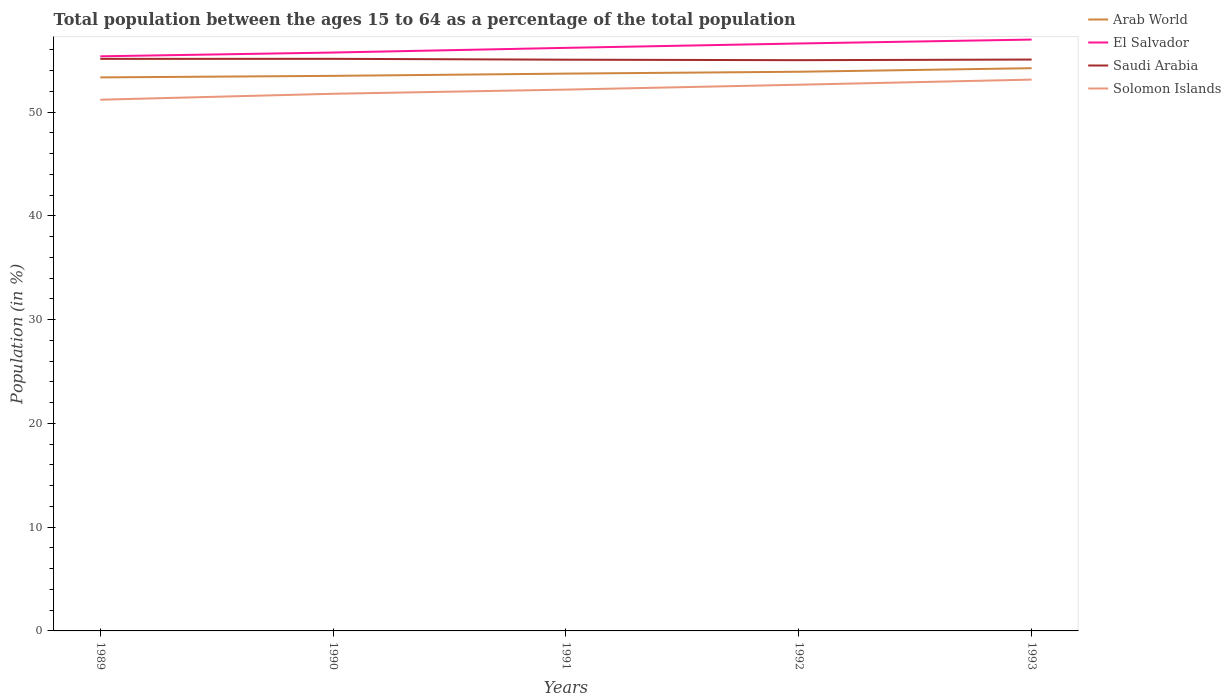Is the number of lines equal to the number of legend labels?
Offer a very short reply. Yes. Across all years, what is the maximum percentage of the population ages 15 to 64 in Solomon Islands?
Make the answer very short. 51.19. In which year was the percentage of the population ages 15 to 64 in Solomon Islands maximum?
Offer a very short reply. 1989. What is the total percentage of the population ages 15 to 64 in El Salvador in the graph?
Provide a succinct answer. -1.61. What is the difference between the highest and the second highest percentage of the population ages 15 to 64 in Arab World?
Give a very brief answer. 0.89. What is the difference between the highest and the lowest percentage of the population ages 15 to 64 in Saudi Arabia?
Your response must be concise. 2. How many lines are there?
Ensure brevity in your answer.  4. How many years are there in the graph?
Give a very brief answer. 5. What is the difference between two consecutive major ticks on the Y-axis?
Make the answer very short. 10. Does the graph contain any zero values?
Keep it short and to the point. No. Does the graph contain grids?
Your response must be concise. No. Where does the legend appear in the graph?
Provide a short and direct response. Top right. What is the title of the graph?
Ensure brevity in your answer.  Total population between the ages 15 to 64 as a percentage of the total population. What is the label or title of the Y-axis?
Offer a very short reply. Population (in %). What is the Population (in %) in Arab World in 1989?
Your response must be concise. 53.35. What is the Population (in %) of El Salvador in 1989?
Make the answer very short. 55.38. What is the Population (in %) of Saudi Arabia in 1989?
Offer a very short reply. 55.13. What is the Population (in %) of Solomon Islands in 1989?
Ensure brevity in your answer.  51.19. What is the Population (in %) in Arab World in 1990?
Offer a very short reply. 53.49. What is the Population (in %) of El Salvador in 1990?
Provide a succinct answer. 55.74. What is the Population (in %) in Saudi Arabia in 1990?
Give a very brief answer. 55.13. What is the Population (in %) of Solomon Islands in 1990?
Provide a short and direct response. 51.77. What is the Population (in %) of Arab World in 1991?
Provide a short and direct response. 53.71. What is the Population (in %) of El Salvador in 1991?
Your answer should be very brief. 56.19. What is the Population (in %) in Saudi Arabia in 1991?
Ensure brevity in your answer.  55.05. What is the Population (in %) of Solomon Islands in 1991?
Your response must be concise. 52.17. What is the Population (in %) in Arab World in 1992?
Make the answer very short. 53.89. What is the Population (in %) in El Salvador in 1992?
Ensure brevity in your answer.  56.61. What is the Population (in %) of Saudi Arabia in 1992?
Your answer should be very brief. 55.01. What is the Population (in %) in Solomon Islands in 1992?
Offer a very short reply. 52.64. What is the Population (in %) of Arab World in 1993?
Your response must be concise. 54.23. What is the Population (in %) of El Salvador in 1993?
Ensure brevity in your answer.  56.99. What is the Population (in %) in Saudi Arabia in 1993?
Keep it short and to the point. 55.07. What is the Population (in %) in Solomon Islands in 1993?
Provide a short and direct response. 53.13. Across all years, what is the maximum Population (in %) in Arab World?
Ensure brevity in your answer.  54.23. Across all years, what is the maximum Population (in %) in El Salvador?
Your answer should be compact. 56.99. Across all years, what is the maximum Population (in %) in Saudi Arabia?
Keep it short and to the point. 55.13. Across all years, what is the maximum Population (in %) of Solomon Islands?
Give a very brief answer. 53.13. Across all years, what is the minimum Population (in %) in Arab World?
Offer a terse response. 53.35. Across all years, what is the minimum Population (in %) of El Salvador?
Your answer should be very brief. 55.38. Across all years, what is the minimum Population (in %) in Saudi Arabia?
Give a very brief answer. 55.01. Across all years, what is the minimum Population (in %) of Solomon Islands?
Ensure brevity in your answer.  51.19. What is the total Population (in %) of Arab World in the graph?
Offer a terse response. 268.67. What is the total Population (in %) in El Salvador in the graph?
Keep it short and to the point. 280.91. What is the total Population (in %) in Saudi Arabia in the graph?
Make the answer very short. 275.39. What is the total Population (in %) of Solomon Islands in the graph?
Provide a succinct answer. 260.9. What is the difference between the Population (in %) of Arab World in 1989 and that in 1990?
Ensure brevity in your answer.  -0.15. What is the difference between the Population (in %) of El Salvador in 1989 and that in 1990?
Your response must be concise. -0.36. What is the difference between the Population (in %) in Saudi Arabia in 1989 and that in 1990?
Your answer should be very brief. -0. What is the difference between the Population (in %) in Solomon Islands in 1989 and that in 1990?
Give a very brief answer. -0.57. What is the difference between the Population (in %) in Arab World in 1989 and that in 1991?
Provide a short and direct response. -0.36. What is the difference between the Population (in %) in El Salvador in 1989 and that in 1991?
Your answer should be compact. -0.81. What is the difference between the Population (in %) of Saudi Arabia in 1989 and that in 1991?
Offer a very short reply. 0.08. What is the difference between the Population (in %) of Solomon Islands in 1989 and that in 1991?
Your answer should be compact. -0.97. What is the difference between the Population (in %) in Arab World in 1989 and that in 1992?
Provide a short and direct response. -0.54. What is the difference between the Population (in %) of El Salvador in 1989 and that in 1992?
Offer a terse response. -1.24. What is the difference between the Population (in %) in Saudi Arabia in 1989 and that in 1992?
Keep it short and to the point. 0.13. What is the difference between the Population (in %) in Solomon Islands in 1989 and that in 1992?
Offer a terse response. -1.44. What is the difference between the Population (in %) of Arab World in 1989 and that in 1993?
Your response must be concise. -0.89. What is the difference between the Population (in %) of El Salvador in 1989 and that in 1993?
Your answer should be very brief. -1.61. What is the difference between the Population (in %) in Saudi Arabia in 1989 and that in 1993?
Your response must be concise. 0.07. What is the difference between the Population (in %) in Solomon Islands in 1989 and that in 1993?
Your response must be concise. -1.94. What is the difference between the Population (in %) in Arab World in 1990 and that in 1991?
Your answer should be compact. -0.22. What is the difference between the Population (in %) in El Salvador in 1990 and that in 1991?
Your response must be concise. -0.45. What is the difference between the Population (in %) of Saudi Arabia in 1990 and that in 1991?
Offer a terse response. 0.08. What is the difference between the Population (in %) of Solomon Islands in 1990 and that in 1991?
Your answer should be compact. -0.4. What is the difference between the Population (in %) of Arab World in 1990 and that in 1992?
Give a very brief answer. -0.4. What is the difference between the Population (in %) of El Salvador in 1990 and that in 1992?
Your response must be concise. -0.87. What is the difference between the Population (in %) of Saudi Arabia in 1990 and that in 1992?
Offer a very short reply. 0.13. What is the difference between the Population (in %) of Solomon Islands in 1990 and that in 1992?
Offer a terse response. -0.87. What is the difference between the Population (in %) of Arab World in 1990 and that in 1993?
Offer a terse response. -0.74. What is the difference between the Population (in %) in El Salvador in 1990 and that in 1993?
Provide a short and direct response. -1.25. What is the difference between the Population (in %) in Saudi Arabia in 1990 and that in 1993?
Offer a terse response. 0.07. What is the difference between the Population (in %) of Solomon Islands in 1990 and that in 1993?
Your response must be concise. -1.36. What is the difference between the Population (in %) in Arab World in 1991 and that in 1992?
Keep it short and to the point. -0.18. What is the difference between the Population (in %) of El Salvador in 1991 and that in 1992?
Your answer should be compact. -0.42. What is the difference between the Population (in %) of Saudi Arabia in 1991 and that in 1992?
Your answer should be very brief. 0.05. What is the difference between the Population (in %) of Solomon Islands in 1991 and that in 1992?
Offer a terse response. -0.47. What is the difference between the Population (in %) of Arab World in 1991 and that in 1993?
Ensure brevity in your answer.  -0.52. What is the difference between the Population (in %) of El Salvador in 1991 and that in 1993?
Provide a succinct answer. -0.8. What is the difference between the Population (in %) of Saudi Arabia in 1991 and that in 1993?
Your response must be concise. -0.01. What is the difference between the Population (in %) of Solomon Islands in 1991 and that in 1993?
Provide a succinct answer. -0.96. What is the difference between the Population (in %) in Arab World in 1992 and that in 1993?
Your answer should be very brief. -0.34. What is the difference between the Population (in %) in El Salvador in 1992 and that in 1993?
Provide a succinct answer. -0.38. What is the difference between the Population (in %) in Saudi Arabia in 1992 and that in 1993?
Offer a terse response. -0.06. What is the difference between the Population (in %) of Solomon Islands in 1992 and that in 1993?
Your answer should be very brief. -0.49. What is the difference between the Population (in %) of Arab World in 1989 and the Population (in %) of El Salvador in 1990?
Keep it short and to the point. -2.39. What is the difference between the Population (in %) of Arab World in 1989 and the Population (in %) of Saudi Arabia in 1990?
Make the answer very short. -1.79. What is the difference between the Population (in %) in Arab World in 1989 and the Population (in %) in Solomon Islands in 1990?
Provide a succinct answer. 1.58. What is the difference between the Population (in %) of El Salvador in 1989 and the Population (in %) of Saudi Arabia in 1990?
Your answer should be compact. 0.24. What is the difference between the Population (in %) in El Salvador in 1989 and the Population (in %) in Solomon Islands in 1990?
Offer a very short reply. 3.61. What is the difference between the Population (in %) in Saudi Arabia in 1989 and the Population (in %) in Solomon Islands in 1990?
Ensure brevity in your answer.  3.36. What is the difference between the Population (in %) of Arab World in 1989 and the Population (in %) of El Salvador in 1991?
Give a very brief answer. -2.85. What is the difference between the Population (in %) of Arab World in 1989 and the Population (in %) of Saudi Arabia in 1991?
Provide a succinct answer. -1.71. What is the difference between the Population (in %) in Arab World in 1989 and the Population (in %) in Solomon Islands in 1991?
Give a very brief answer. 1.18. What is the difference between the Population (in %) of El Salvador in 1989 and the Population (in %) of Saudi Arabia in 1991?
Offer a very short reply. 0.33. What is the difference between the Population (in %) in El Salvador in 1989 and the Population (in %) in Solomon Islands in 1991?
Provide a succinct answer. 3.21. What is the difference between the Population (in %) in Saudi Arabia in 1989 and the Population (in %) in Solomon Islands in 1991?
Your response must be concise. 2.96. What is the difference between the Population (in %) in Arab World in 1989 and the Population (in %) in El Salvador in 1992?
Your answer should be compact. -3.27. What is the difference between the Population (in %) in Arab World in 1989 and the Population (in %) in Saudi Arabia in 1992?
Make the answer very short. -1.66. What is the difference between the Population (in %) of Arab World in 1989 and the Population (in %) of Solomon Islands in 1992?
Provide a succinct answer. 0.71. What is the difference between the Population (in %) in El Salvador in 1989 and the Population (in %) in Saudi Arabia in 1992?
Offer a very short reply. 0.37. What is the difference between the Population (in %) in El Salvador in 1989 and the Population (in %) in Solomon Islands in 1992?
Give a very brief answer. 2.74. What is the difference between the Population (in %) in Saudi Arabia in 1989 and the Population (in %) in Solomon Islands in 1992?
Offer a very short reply. 2.49. What is the difference between the Population (in %) in Arab World in 1989 and the Population (in %) in El Salvador in 1993?
Ensure brevity in your answer.  -3.64. What is the difference between the Population (in %) of Arab World in 1989 and the Population (in %) of Saudi Arabia in 1993?
Your response must be concise. -1.72. What is the difference between the Population (in %) in Arab World in 1989 and the Population (in %) in Solomon Islands in 1993?
Your response must be concise. 0.21. What is the difference between the Population (in %) in El Salvador in 1989 and the Population (in %) in Saudi Arabia in 1993?
Your answer should be very brief. 0.31. What is the difference between the Population (in %) in El Salvador in 1989 and the Population (in %) in Solomon Islands in 1993?
Provide a short and direct response. 2.25. What is the difference between the Population (in %) of Saudi Arabia in 1989 and the Population (in %) of Solomon Islands in 1993?
Offer a terse response. 2. What is the difference between the Population (in %) of Arab World in 1990 and the Population (in %) of El Salvador in 1991?
Ensure brevity in your answer.  -2.7. What is the difference between the Population (in %) in Arab World in 1990 and the Population (in %) in Saudi Arabia in 1991?
Give a very brief answer. -1.56. What is the difference between the Population (in %) in Arab World in 1990 and the Population (in %) in Solomon Islands in 1991?
Make the answer very short. 1.33. What is the difference between the Population (in %) of El Salvador in 1990 and the Population (in %) of Saudi Arabia in 1991?
Your response must be concise. 0.69. What is the difference between the Population (in %) of El Salvador in 1990 and the Population (in %) of Solomon Islands in 1991?
Your answer should be very brief. 3.57. What is the difference between the Population (in %) of Saudi Arabia in 1990 and the Population (in %) of Solomon Islands in 1991?
Your response must be concise. 2.97. What is the difference between the Population (in %) in Arab World in 1990 and the Population (in %) in El Salvador in 1992?
Provide a short and direct response. -3.12. What is the difference between the Population (in %) in Arab World in 1990 and the Population (in %) in Saudi Arabia in 1992?
Keep it short and to the point. -1.51. What is the difference between the Population (in %) in Arab World in 1990 and the Population (in %) in Solomon Islands in 1992?
Ensure brevity in your answer.  0.85. What is the difference between the Population (in %) in El Salvador in 1990 and the Population (in %) in Saudi Arabia in 1992?
Ensure brevity in your answer.  0.74. What is the difference between the Population (in %) in El Salvador in 1990 and the Population (in %) in Solomon Islands in 1992?
Your answer should be compact. 3.1. What is the difference between the Population (in %) of Saudi Arabia in 1990 and the Population (in %) of Solomon Islands in 1992?
Make the answer very short. 2.5. What is the difference between the Population (in %) in Arab World in 1990 and the Population (in %) in El Salvador in 1993?
Your response must be concise. -3.5. What is the difference between the Population (in %) of Arab World in 1990 and the Population (in %) of Saudi Arabia in 1993?
Ensure brevity in your answer.  -1.57. What is the difference between the Population (in %) in Arab World in 1990 and the Population (in %) in Solomon Islands in 1993?
Your response must be concise. 0.36. What is the difference between the Population (in %) in El Salvador in 1990 and the Population (in %) in Saudi Arabia in 1993?
Keep it short and to the point. 0.68. What is the difference between the Population (in %) of El Salvador in 1990 and the Population (in %) of Solomon Islands in 1993?
Give a very brief answer. 2.61. What is the difference between the Population (in %) in Saudi Arabia in 1990 and the Population (in %) in Solomon Islands in 1993?
Your answer should be compact. 2. What is the difference between the Population (in %) in Arab World in 1991 and the Population (in %) in El Salvador in 1992?
Your response must be concise. -2.9. What is the difference between the Population (in %) in Arab World in 1991 and the Population (in %) in Saudi Arabia in 1992?
Provide a short and direct response. -1.3. What is the difference between the Population (in %) of Arab World in 1991 and the Population (in %) of Solomon Islands in 1992?
Make the answer very short. 1.07. What is the difference between the Population (in %) of El Salvador in 1991 and the Population (in %) of Saudi Arabia in 1992?
Ensure brevity in your answer.  1.19. What is the difference between the Population (in %) in El Salvador in 1991 and the Population (in %) in Solomon Islands in 1992?
Keep it short and to the point. 3.55. What is the difference between the Population (in %) in Saudi Arabia in 1991 and the Population (in %) in Solomon Islands in 1992?
Make the answer very short. 2.41. What is the difference between the Population (in %) of Arab World in 1991 and the Population (in %) of El Salvador in 1993?
Keep it short and to the point. -3.28. What is the difference between the Population (in %) of Arab World in 1991 and the Population (in %) of Saudi Arabia in 1993?
Give a very brief answer. -1.36. What is the difference between the Population (in %) in Arab World in 1991 and the Population (in %) in Solomon Islands in 1993?
Your answer should be very brief. 0.58. What is the difference between the Population (in %) in El Salvador in 1991 and the Population (in %) in Saudi Arabia in 1993?
Give a very brief answer. 1.13. What is the difference between the Population (in %) in El Salvador in 1991 and the Population (in %) in Solomon Islands in 1993?
Offer a terse response. 3.06. What is the difference between the Population (in %) in Saudi Arabia in 1991 and the Population (in %) in Solomon Islands in 1993?
Offer a very short reply. 1.92. What is the difference between the Population (in %) in Arab World in 1992 and the Population (in %) in El Salvador in 1993?
Make the answer very short. -3.1. What is the difference between the Population (in %) in Arab World in 1992 and the Population (in %) in Saudi Arabia in 1993?
Your response must be concise. -1.18. What is the difference between the Population (in %) in Arab World in 1992 and the Population (in %) in Solomon Islands in 1993?
Your answer should be very brief. 0.76. What is the difference between the Population (in %) in El Salvador in 1992 and the Population (in %) in Saudi Arabia in 1993?
Ensure brevity in your answer.  1.55. What is the difference between the Population (in %) in El Salvador in 1992 and the Population (in %) in Solomon Islands in 1993?
Your answer should be very brief. 3.48. What is the difference between the Population (in %) in Saudi Arabia in 1992 and the Population (in %) in Solomon Islands in 1993?
Offer a terse response. 1.87. What is the average Population (in %) of Arab World per year?
Provide a succinct answer. 53.73. What is the average Population (in %) of El Salvador per year?
Your answer should be compact. 56.18. What is the average Population (in %) in Saudi Arabia per year?
Keep it short and to the point. 55.08. What is the average Population (in %) of Solomon Islands per year?
Your response must be concise. 52.18. In the year 1989, what is the difference between the Population (in %) in Arab World and Population (in %) in El Salvador?
Provide a short and direct response. -2.03. In the year 1989, what is the difference between the Population (in %) of Arab World and Population (in %) of Saudi Arabia?
Provide a succinct answer. -1.79. In the year 1989, what is the difference between the Population (in %) of Arab World and Population (in %) of Solomon Islands?
Offer a terse response. 2.15. In the year 1989, what is the difference between the Population (in %) in El Salvador and Population (in %) in Saudi Arabia?
Offer a very short reply. 0.25. In the year 1989, what is the difference between the Population (in %) in El Salvador and Population (in %) in Solomon Islands?
Make the answer very short. 4.18. In the year 1989, what is the difference between the Population (in %) in Saudi Arabia and Population (in %) in Solomon Islands?
Provide a short and direct response. 3.94. In the year 1990, what is the difference between the Population (in %) of Arab World and Population (in %) of El Salvador?
Offer a terse response. -2.25. In the year 1990, what is the difference between the Population (in %) in Arab World and Population (in %) in Saudi Arabia?
Keep it short and to the point. -1.64. In the year 1990, what is the difference between the Population (in %) in Arab World and Population (in %) in Solomon Islands?
Provide a short and direct response. 1.73. In the year 1990, what is the difference between the Population (in %) of El Salvador and Population (in %) of Saudi Arabia?
Provide a short and direct response. 0.61. In the year 1990, what is the difference between the Population (in %) of El Salvador and Population (in %) of Solomon Islands?
Ensure brevity in your answer.  3.97. In the year 1990, what is the difference between the Population (in %) of Saudi Arabia and Population (in %) of Solomon Islands?
Your answer should be compact. 3.37. In the year 1991, what is the difference between the Population (in %) of Arab World and Population (in %) of El Salvador?
Your response must be concise. -2.48. In the year 1991, what is the difference between the Population (in %) in Arab World and Population (in %) in Saudi Arabia?
Keep it short and to the point. -1.34. In the year 1991, what is the difference between the Population (in %) in Arab World and Population (in %) in Solomon Islands?
Keep it short and to the point. 1.54. In the year 1991, what is the difference between the Population (in %) of El Salvador and Population (in %) of Saudi Arabia?
Make the answer very short. 1.14. In the year 1991, what is the difference between the Population (in %) in El Salvador and Population (in %) in Solomon Islands?
Offer a very short reply. 4.02. In the year 1991, what is the difference between the Population (in %) of Saudi Arabia and Population (in %) of Solomon Islands?
Your answer should be very brief. 2.88. In the year 1992, what is the difference between the Population (in %) of Arab World and Population (in %) of El Salvador?
Provide a succinct answer. -2.72. In the year 1992, what is the difference between the Population (in %) in Arab World and Population (in %) in Saudi Arabia?
Your answer should be very brief. -1.12. In the year 1992, what is the difference between the Population (in %) in El Salvador and Population (in %) in Saudi Arabia?
Provide a short and direct response. 1.61. In the year 1992, what is the difference between the Population (in %) of El Salvador and Population (in %) of Solomon Islands?
Your response must be concise. 3.97. In the year 1992, what is the difference between the Population (in %) of Saudi Arabia and Population (in %) of Solomon Islands?
Keep it short and to the point. 2.37. In the year 1993, what is the difference between the Population (in %) in Arab World and Population (in %) in El Salvador?
Keep it short and to the point. -2.76. In the year 1993, what is the difference between the Population (in %) of Arab World and Population (in %) of Saudi Arabia?
Your response must be concise. -0.83. In the year 1993, what is the difference between the Population (in %) in Arab World and Population (in %) in Solomon Islands?
Your answer should be very brief. 1.1. In the year 1993, what is the difference between the Population (in %) of El Salvador and Population (in %) of Saudi Arabia?
Offer a terse response. 1.92. In the year 1993, what is the difference between the Population (in %) of El Salvador and Population (in %) of Solomon Islands?
Keep it short and to the point. 3.86. In the year 1993, what is the difference between the Population (in %) of Saudi Arabia and Population (in %) of Solomon Islands?
Offer a terse response. 1.93. What is the ratio of the Population (in %) in Arab World in 1989 to that in 1990?
Offer a terse response. 1. What is the ratio of the Population (in %) of El Salvador in 1989 to that in 1990?
Provide a short and direct response. 0.99. What is the ratio of the Population (in %) of Solomon Islands in 1989 to that in 1990?
Provide a short and direct response. 0.99. What is the ratio of the Population (in %) in Arab World in 1989 to that in 1991?
Make the answer very short. 0.99. What is the ratio of the Population (in %) in El Salvador in 1989 to that in 1991?
Offer a terse response. 0.99. What is the ratio of the Population (in %) in Saudi Arabia in 1989 to that in 1991?
Keep it short and to the point. 1. What is the ratio of the Population (in %) of Solomon Islands in 1989 to that in 1991?
Your response must be concise. 0.98. What is the ratio of the Population (in %) of Arab World in 1989 to that in 1992?
Your response must be concise. 0.99. What is the ratio of the Population (in %) of El Salvador in 1989 to that in 1992?
Offer a terse response. 0.98. What is the ratio of the Population (in %) of Solomon Islands in 1989 to that in 1992?
Offer a very short reply. 0.97. What is the ratio of the Population (in %) of Arab World in 1989 to that in 1993?
Keep it short and to the point. 0.98. What is the ratio of the Population (in %) of El Salvador in 1989 to that in 1993?
Ensure brevity in your answer.  0.97. What is the ratio of the Population (in %) in Saudi Arabia in 1989 to that in 1993?
Your answer should be very brief. 1. What is the ratio of the Population (in %) in Solomon Islands in 1989 to that in 1993?
Provide a succinct answer. 0.96. What is the ratio of the Population (in %) in Saudi Arabia in 1990 to that in 1991?
Provide a succinct answer. 1. What is the ratio of the Population (in %) in El Salvador in 1990 to that in 1992?
Your answer should be compact. 0.98. What is the ratio of the Population (in %) in Saudi Arabia in 1990 to that in 1992?
Give a very brief answer. 1. What is the ratio of the Population (in %) of Solomon Islands in 1990 to that in 1992?
Ensure brevity in your answer.  0.98. What is the ratio of the Population (in %) of Arab World in 1990 to that in 1993?
Ensure brevity in your answer.  0.99. What is the ratio of the Population (in %) of El Salvador in 1990 to that in 1993?
Offer a terse response. 0.98. What is the ratio of the Population (in %) in Saudi Arabia in 1990 to that in 1993?
Ensure brevity in your answer.  1. What is the ratio of the Population (in %) of Solomon Islands in 1990 to that in 1993?
Your answer should be very brief. 0.97. What is the ratio of the Population (in %) in Arab World in 1991 to that in 1992?
Provide a short and direct response. 1. What is the ratio of the Population (in %) of El Salvador in 1991 to that in 1992?
Your answer should be compact. 0.99. What is the ratio of the Population (in %) in Solomon Islands in 1991 to that in 1992?
Your answer should be compact. 0.99. What is the ratio of the Population (in %) of Arab World in 1991 to that in 1993?
Provide a short and direct response. 0.99. What is the ratio of the Population (in %) in El Salvador in 1991 to that in 1993?
Provide a short and direct response. 0.99. What is the ratio of the Population (in %) in Saudi Arabia in 1991 to that in 1993?
Keep it short and to the point. 1. What is the ratio of the Population (in %) in Solomon Islands in 1991 to that in 1993?
Provide a short and direct response. 0.98. What is the ratio of the Population (in %) of Arab World in 1992 to that in 1993?
Give a very brief answer. 0.99. What is the ratio of the Population (in %) in El Salvador in 1992 to that in 1993?
Provide a short and direct response. 0.99. What is the ratio of the Population (in %) of Saudi Arabia in 1992 to that in 1993?
Your answer should be compact. 1. What is the ratio of the Population (in %) of Solomon Islands in 1992 to that in 1993?
Provide a short and direct response. 0.99. What is the difference between the highest and the second highest Population (in %) of Arab World?
Your response must be concise. 0.34. What is the difference between the highest and the second highest Population (in %) of El Salvador?
Provide a succinct answer. 0.38. What is the difference between the highest and the second highest Population (in %) of Saudi Arabia?
Your response must be concise. 0. What is the difference between the highest and the second highest Population (in %) of Solomon Islands?
Offer a very short reply. 0.49. What is the difference between the highest and the lowest Population (in %) of Arab World?
Offer a very short reply. 0.89. What is the difference between the highest and the lowest Population (in %) in El Salvador?
Your answer should be compact. 1.61. What is the difference between the highest and the lowest Population (in %) in Saudi Arabia?
Your answer should be very brief. 0.13. What is the difference between the highest and the lowest Population (in %) of Solomon Islands?
Give a very brief answer. 1.94. 